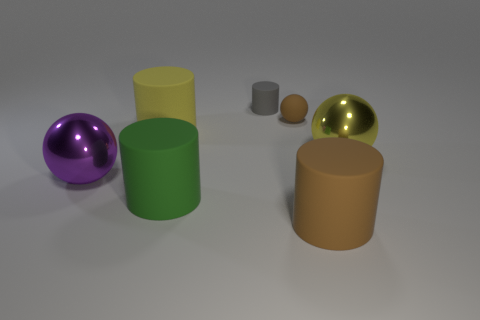What shape is the large matte thing behind the large purple shiny thing?
Offer a terse response. Cylinder. How many large red blocks have the same material as the brown cylinder?
Provide a succinct answer. 0. Are there fewer objects that are in front of the big yellow metallic sphere than tiny cyan shiny spheres?
Your response must be concise. No. How big is the ball left of the large matte thing behind the big purple sphere?
Provide a short and direct response. Large. There is a matte ball; is its color the same as the rubber cylinder on the right side of the small brown rubber object?
Give a very brief answer. Yes. What material is the other thing that is the same size as the gray rubber object?
Provide a succinct answer. Rubber. Is the number of small gray rubber things behind the gray cylinder less than the number of large rubber cylinders behind the big yellow metal ball?
Your response must be concise. Yes. What shape is the big shiny object left of the big yellow thing that is to the right of the large yellow rubber cylinder?
Give a very brief answer. Sphere. Are there any rubber cubes?
Provide a short and direct response. No. There is a big matte object that is behind the big green matte cylinder; what color is it?
Provide a short and direct response. Yellow. 